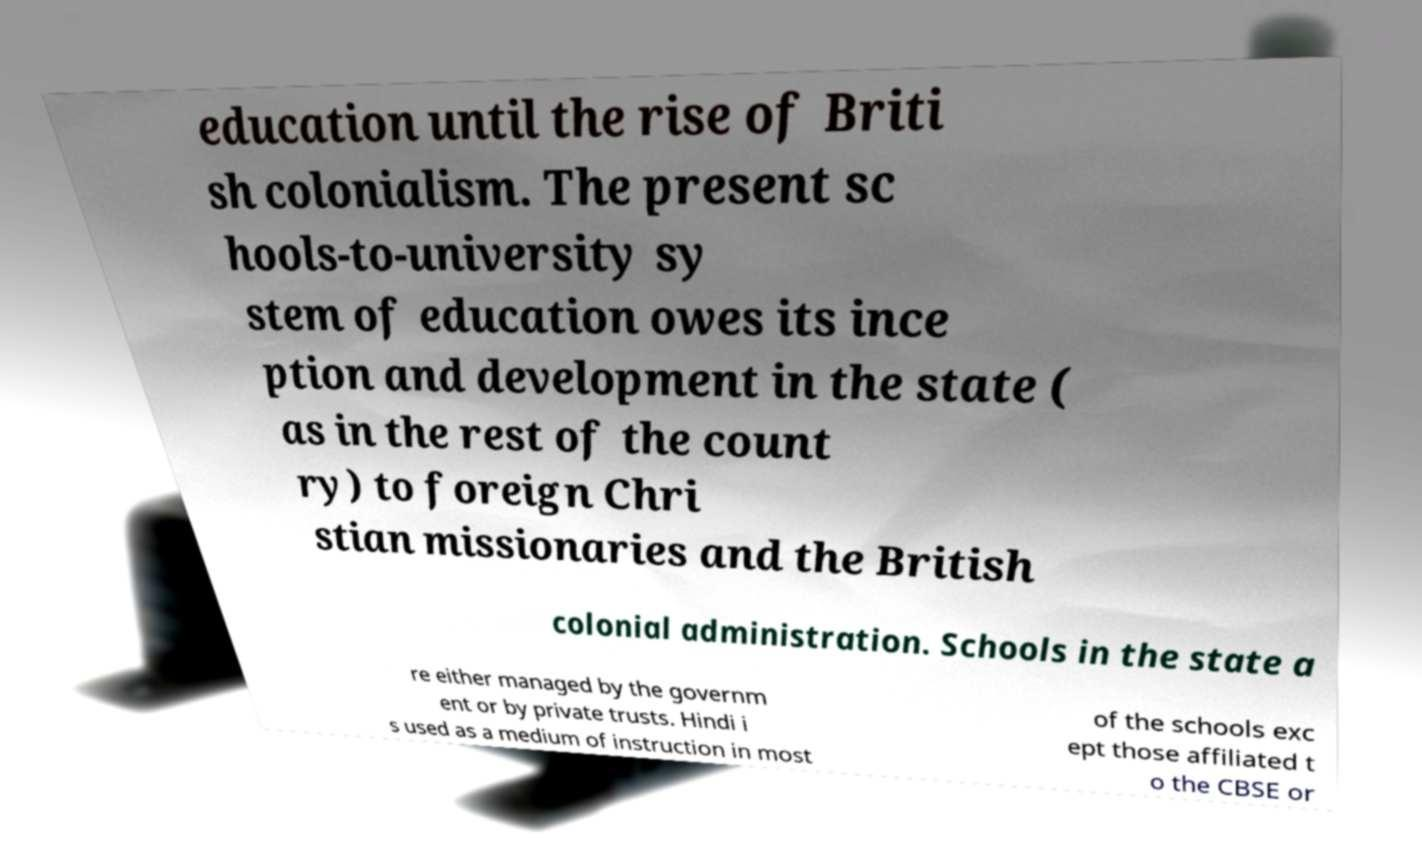What messages or text are displayed in this image? I need them in a readable, typed format. education until the rise of Briti sh colonialism. The present sc hools-to-university sy stem of education owes its ince ption and development in the state ( as in the rest of the count ry) to foreign Chri stian missionaries and the British colonial administration. Schools in the state a re either managed by the governm ent or by private trusts. Hindi i s used as a medium of instruction in most of the schools exc ept those affiliated t o the CBSE or 